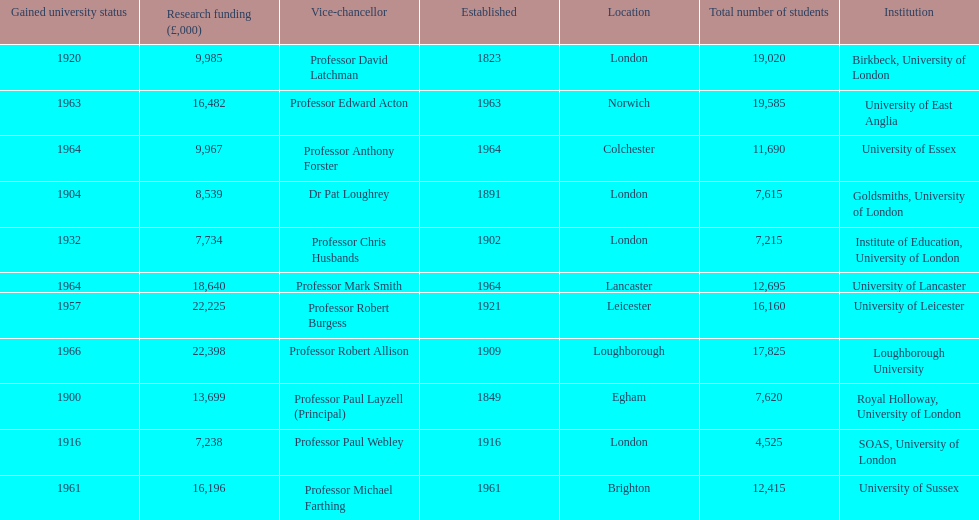What is the most recent institution to gain university status? Loughborough University. 